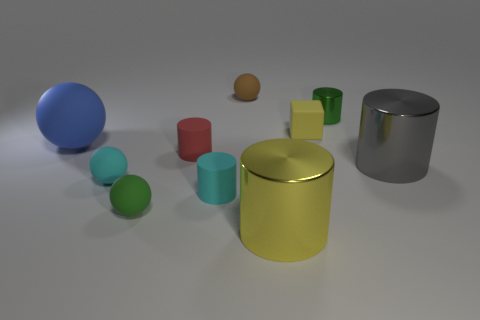Subtract all green rubber balls. How many balls are left? 3 Subtract all gray cylinders. How many cylinders are left? 4 Subtract 1 cubes. How many cubes are left? 0 Subtract all spheres. How many objects are left? 6 Subtract all red cylinders. Subtract all brown balls. How many cylinders are left? 4 Subtract all small purple balls. Subtract all tiny blocks. How many objects are left? 9 Add 4 big metallic cylinders. How many big metallic cylinders are left? 6 Add 4 tiny green balls. How many tiny green balls exist? 5 Subtract 1 green spheres. How many objects are left? 9 